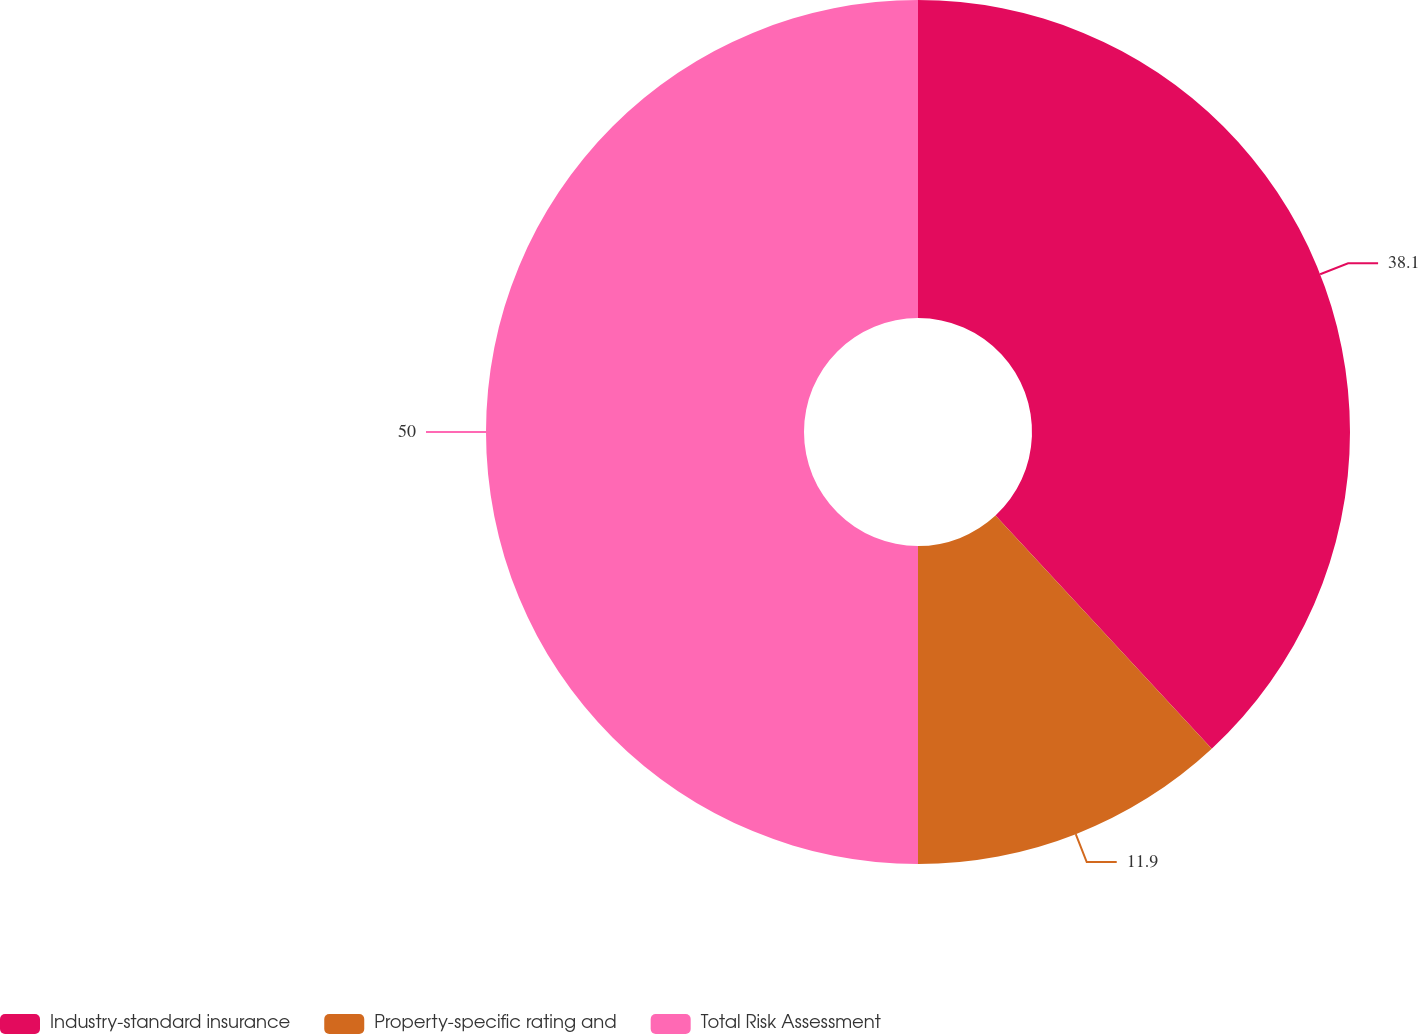<chart> <loc_0><loc_0><loc_500><loc_500><pie_chart><fcel>Industry-standard insurance<fcel>Property-specific rating and<fcel>Total Risk Assessment<nl><fcel>38.1%<fcel>11.9%<fcel>50.0%<nl></chart> 